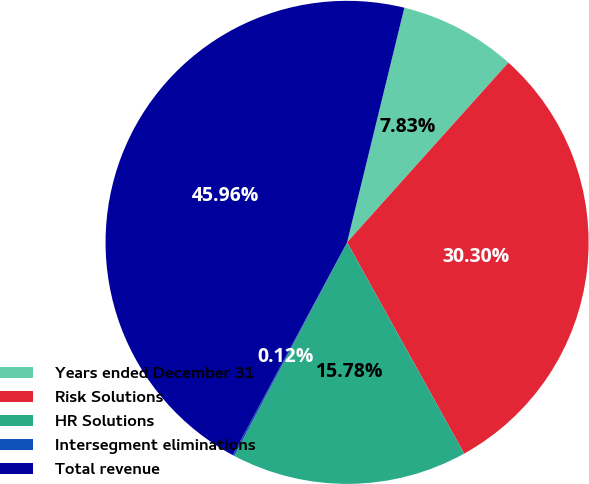<chart> <loc_0><loc_0><loc_500><loc_500><pie_chart><fcel>Years ended December 31<fcel>Risk Solutions<fcel>HR Solutions<fcel>Intersegment eliminations<fcel>Total revenue<nl><fcel>7.83%<fcel>30.3%<fcel>15.78%<fcel>0.12%<fcel>45.96%<nl></chart> 